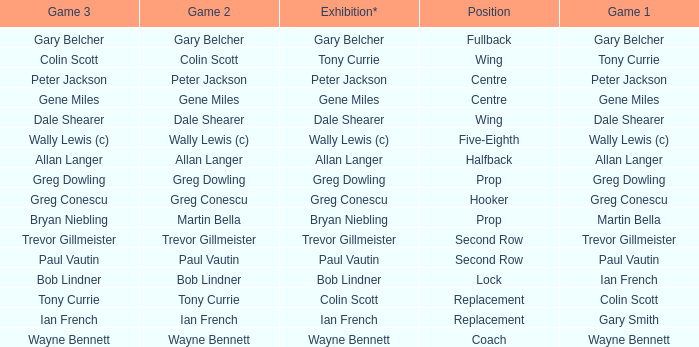Could you parse the entire table? {'header': ['Game 3', 'Game 2', 'Exhibition*', 'Position', 'Game 1'], 'rows': [['Gary Belcher', 'Gary Belcher', 'Gary Belcher', 'Fullback', 'Gary Belcher'], ['Colin Scott', 'Colin Scott', 'Tony Currie', 'Wing', 'Tony Currie'], ['Peter Jackson', 'Peter Jackson', 'Peter Jackson', 'Centre', 'Peter Jackson'], ['Gene Miles', 'Gene Miles', 'Gene Miles', 'Centre', 'Gene Miles'], ['Dale Shearer', 'Dale Shearer', 'Dale Shearer', 'Wing', 'Dale Shearer'], ['Wally Lewis (c)', 'Wally Lewis (c)', 'Wally Lewis (c)', 'Five-Eighth', 'Wally Lewis (c)'], ['Allan Langer', 'Allan Langer', 'Allan Langer', 'Halfback', 'Allan Langer'], ['Greg Dowling', 'Greg Dowling', 'Greg Dowling', 'Prop', 'Greg Dowling'], ['Greg Conescu', 'Greg Conescu', 'Greg Conescu', 'Hooker', 'Greg Conescu'], ['Bryan Niebling', 'Martin Bella', 'Bryan Niebling', 'Prop', 'Martin Bella'], ['Trevor Gillmeister', 'Trevor Gillmeister', 'Trevor Gillmeister', 'Second Row', 'Trevor Gillmeister'], ['Paul Vautin', 'Paul Vautin', 'Paul Vautin', 'Second Row', 'Paul Vautin'], ['Bob Lindner', 'Bob Lindner', 'Bob Lindner', 'Lock', 'Ian French'], ['Tony Currie', 'Tony Currie', 'Colin Scott', 'Replacement', 'Colin Scott'], ['Ian French', 'Ian French', 'Ian French', 'Replacement', 'Gary Smith'], ['Wayne Bennett', 'Wayne Bennett', 'Wayne Bennett', 'Coach', 'Wayne Bennett']]} What game 1 has bob lindner as game 2? Ian French. 